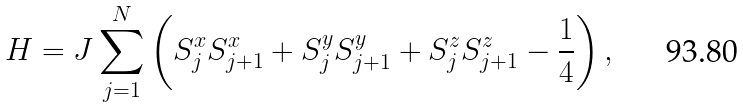<formula> <loc_0><loc_0><loc_500><loc_500>H = J \sum ^ { N } _ { j = 1 } \left ( S ^ { x } _ { j } S ^ { x } _ { j + 1 } + S ^ { y } _ { j } S ^ { y } _ { j + 1 } + S ^ { z } _ { j } S ^ { z } _ { j + 1 } - \frac { 1 } { 4 } \right ) ,</formula> 